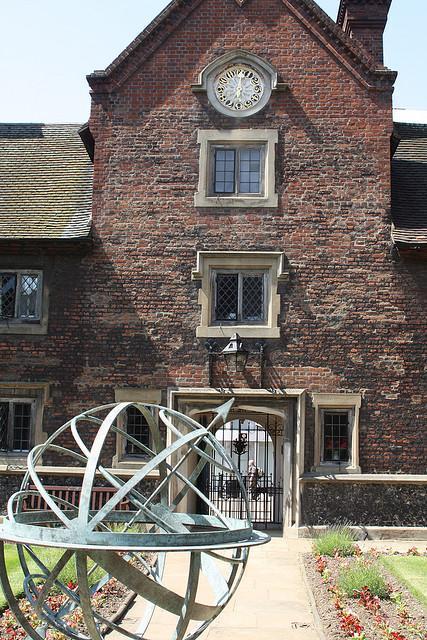How many kites are in the sky?
Give a very brief answer. 0. 